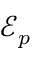<formula> <loc_0><loc_0><loc_500><loc_500>\mathcal { E } _ { p }</formula> 